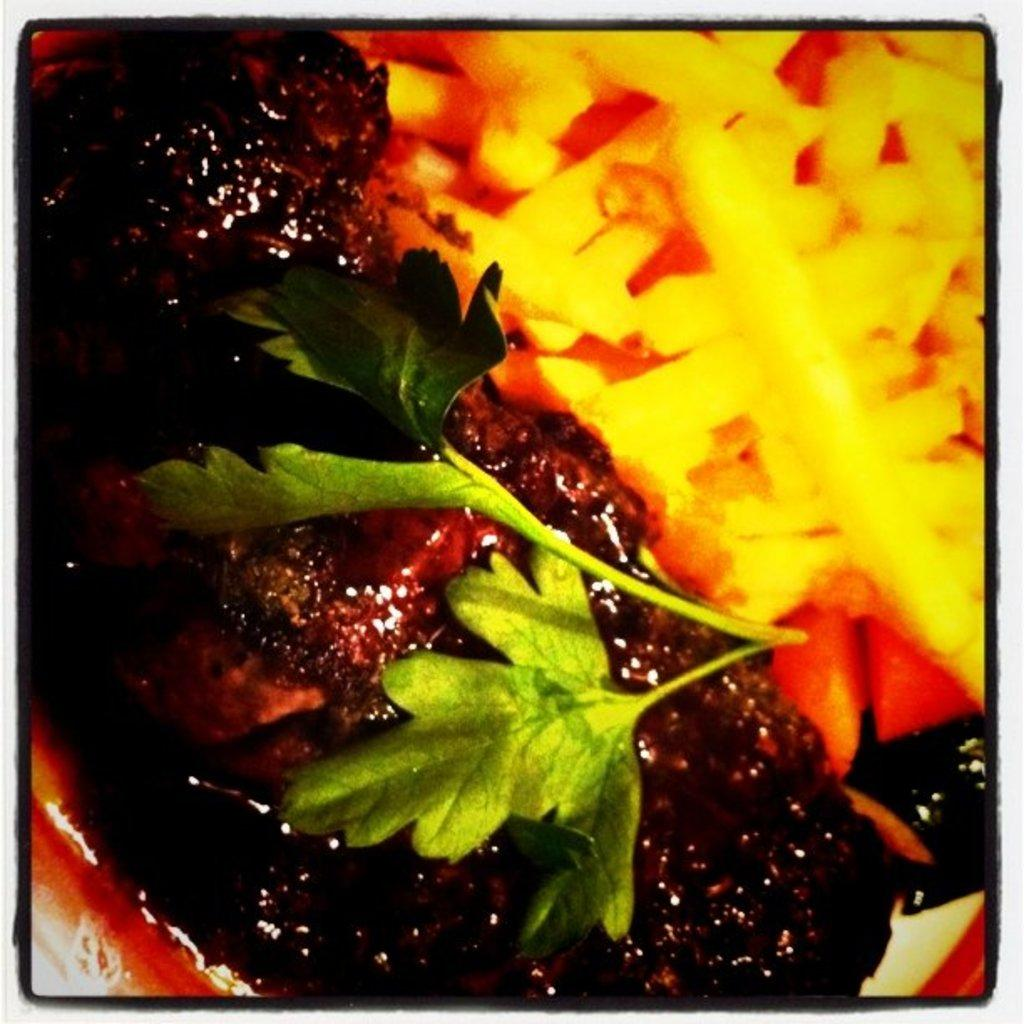What can be said about the nature of the image? The image is edited. What type of object can be seen in the image? There is a food item in the image. Can you identify any specific ingredient in the image? Yes, there is a coriander leaf in the image. How many sheep are visible in the image? There are no sheep present in the image. What type of line can be seen connecting the food item and the coriander leaf? There is no line connecting the food item and the coriander leaf in the image. 